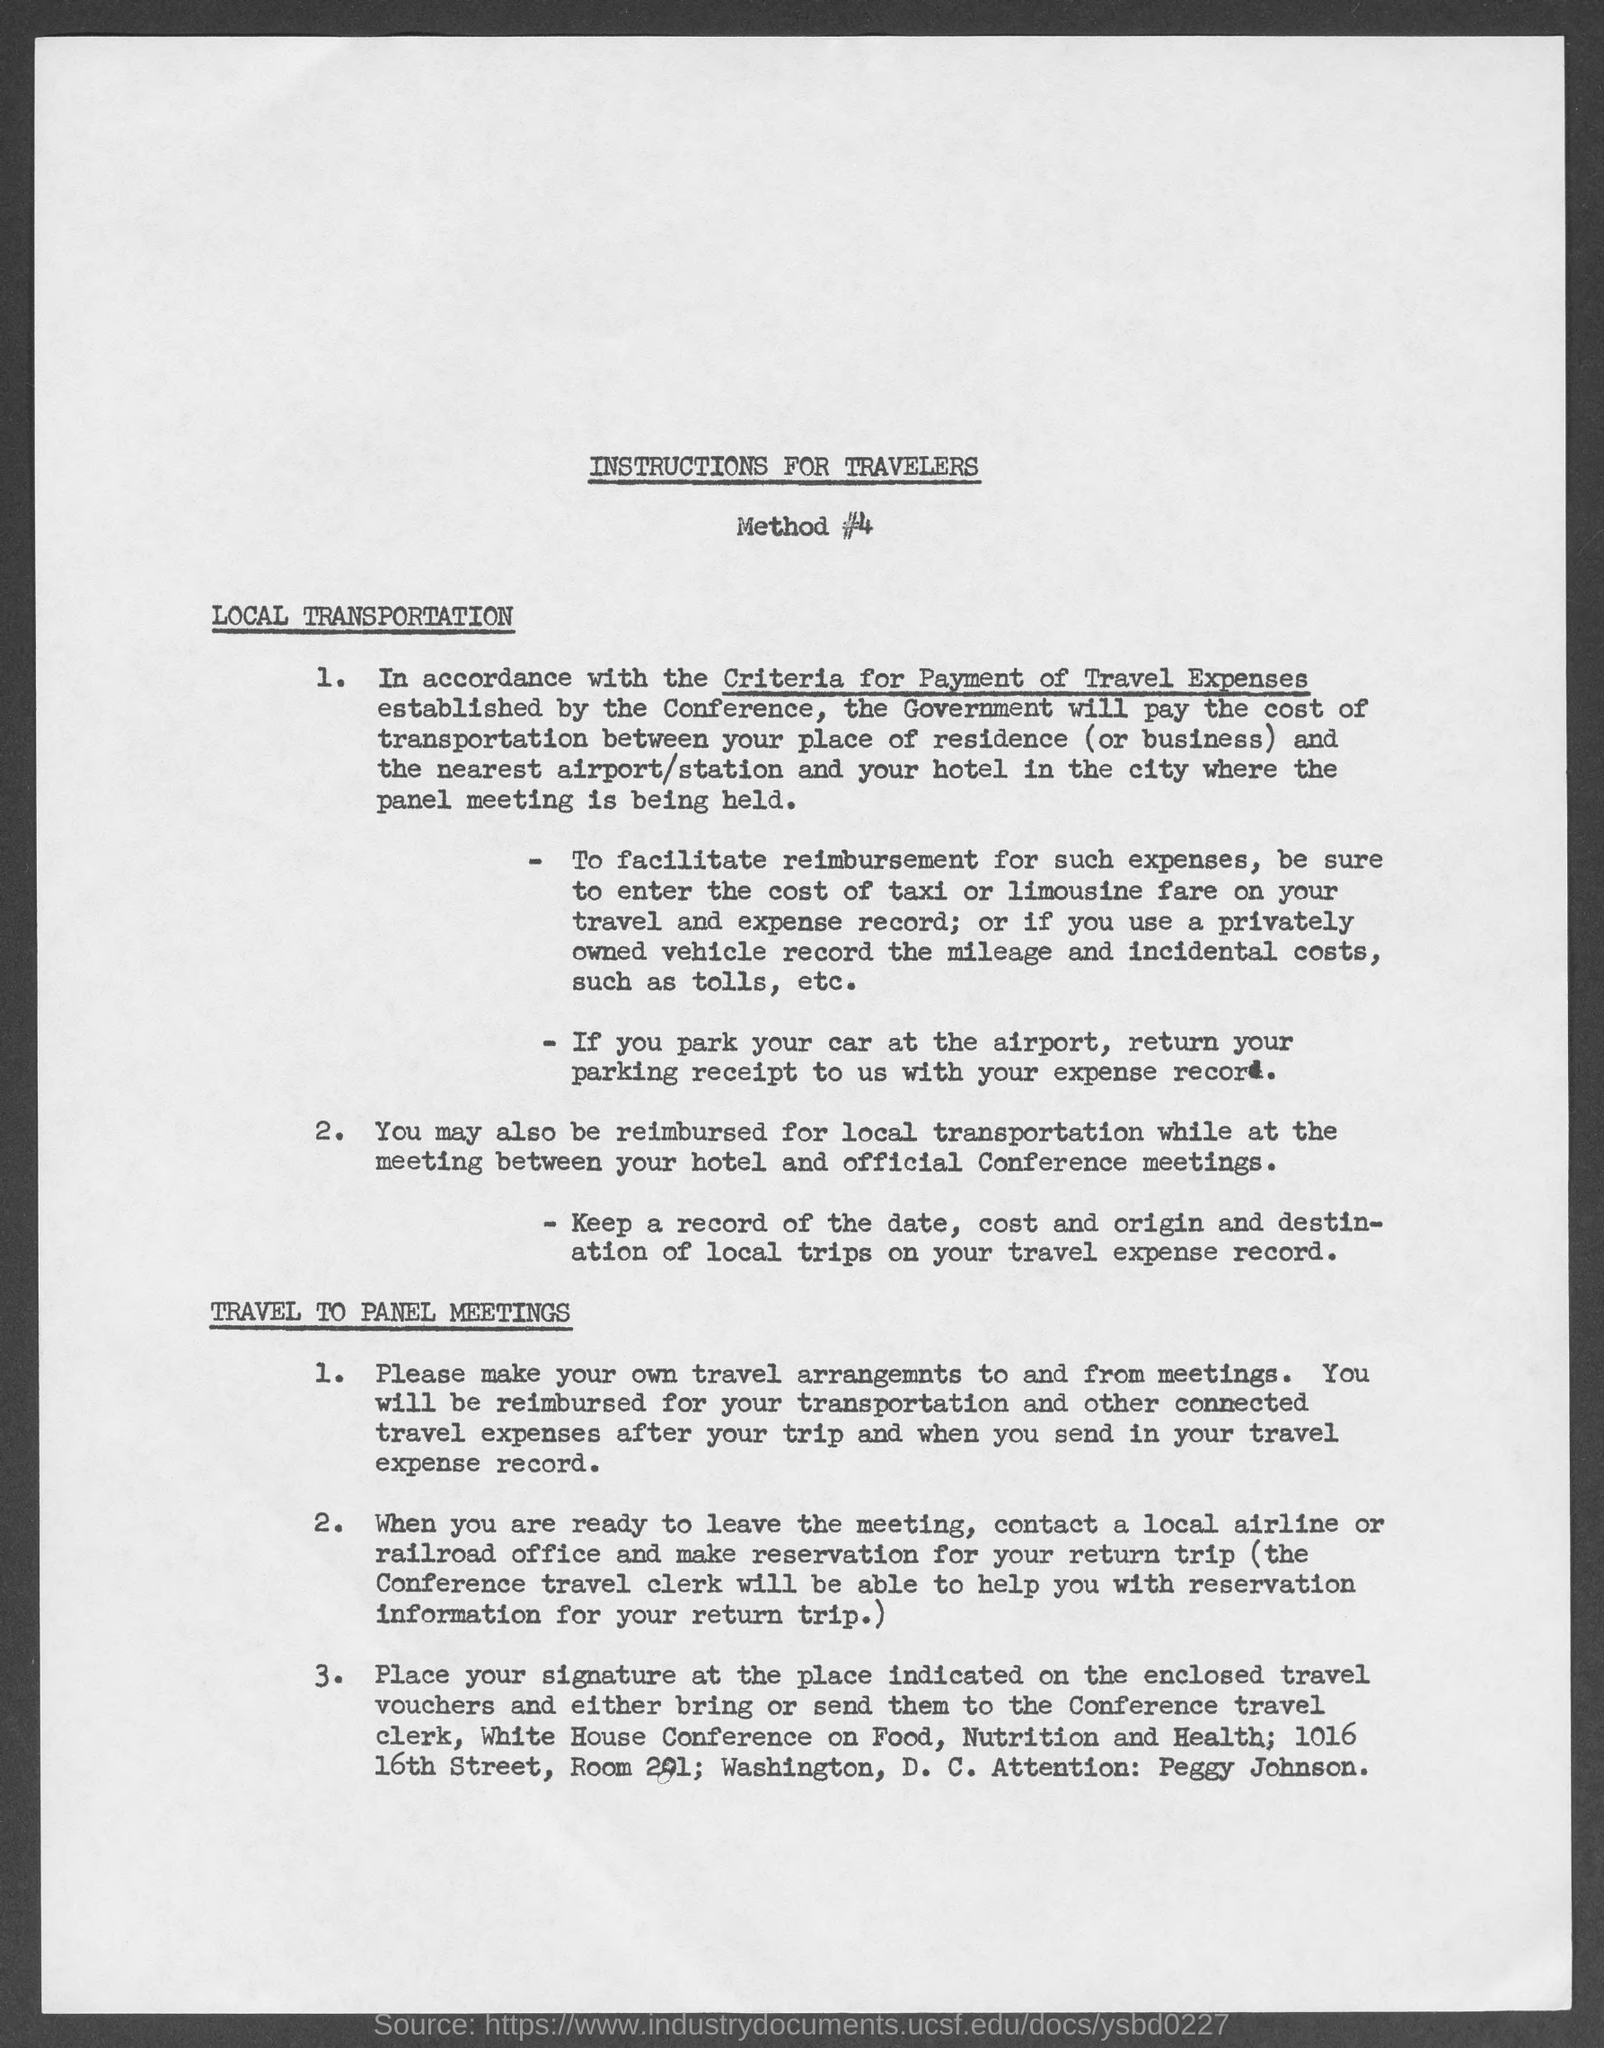Who will pay the cost of transportation?
Make the answer very short. The government. What is to be done if privately owned vehicles are used?
Ensure brevity in your answer.  Record the mileage and incidental costs, such as tolls, etc. Where the signature is to be placed?
Your answer should be very brief. At the place indicated on the enclosed travel vouchers. 